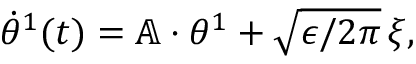Convert formula to latex. <formula><loc_0><loc_0><loc_500><loc_500>\begin{array} { r } { \dot { \theta } ^ { 1 } ( t ) = \mathbb { A } \cdot { \theta } ^ { 1 } + \sqrt { \epsilon / 2 \pi } \, { \xi } , } \end{array}</formula> 